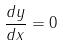Convert formula to latex. <formula><loc_0><loc_0><loc_500><loc_500>\frac { d y } { d x } = 0</formula> 